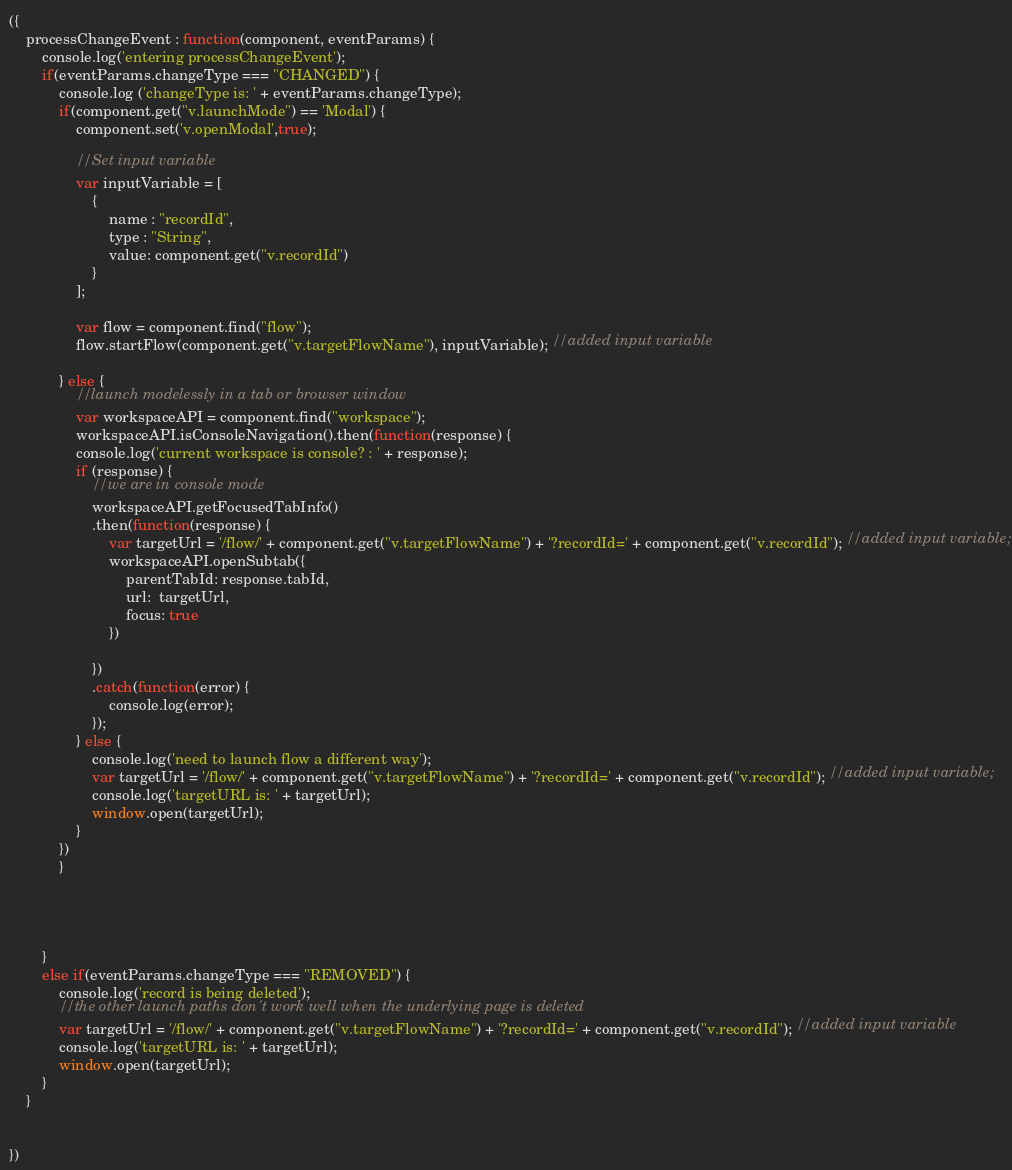Convert code to text. <code><loc_0><loc_0><loc_500><loc_500><_JavaScript_>({
    processChangeEvent : function(component, eventParams) {
        console.log('entering processChangeEvent');
        if(eventParams.changeType === "CHANGED") {
            console.log ('changeType is: ' + eventParams.changeType);
            if(component.get("v.launchMode") == 'Modal') {
                component.set('v.openModal',true);

                //Set input variable
                var inputVariable = [
                    {
                        name : "recordId",
                        type : "String",
                        value: component.get("v.recordId")
                    }
                ];

                var flow = component.find("flow");
                flow.startFlow(component.get("v.targetFlowName"), inputVariable); //added input variable

            } else {
                //launch modelessly in a tab or browser window
                var workspaceAPI = component.find("workspace");
                workspaceAPI.isConsoleNavigation().then(function(response) {
                console.log('current workspace is console? : ' + response);
                if (response) {
                    //we are in console mode
                    workspaceAPI.getFocusedTabInfo()
                    .then(function(response) {
                        var targetUrl = '/flow/' + component.get("v.targetFlowName") + '?recordId=' + component.get("v.recordId"); //added input variable;
                        workspaceAPI.openSubtab({
                            parentTabId: response.tabId,
                            url:  targetUrl,
                            focus: true
                        })
        
                    })
                    .catch(function(error) {
                        console.log(error);
                    });
                } else {
                    console.log('need to launch flow a different way');
                    var targetUrl = '/flow/' + component.get("v.targetFlowName") + '?recordId=' + component.get("v.recordId"); //added input variable;
                    console.log('targetURL is: ' + targetUrl);
                    window.open(targetUrl);
                }
            })
            }
            
        
            

        }   
        else if(eventParams.changeType === "REMOVED") {
            console.log('record is being deleted');
            //the other launch paths don't work well when the underlying page is deleted
            var targetUrl = '/flow/' + component.get("v.targetFlowName") + '?recordId=' + component.get("v.recordId"); //added input variable
            console.log('targetURL is: ' + targetUrl);
            window.open(targetUrl);
        }
    }

    
})
</code> 